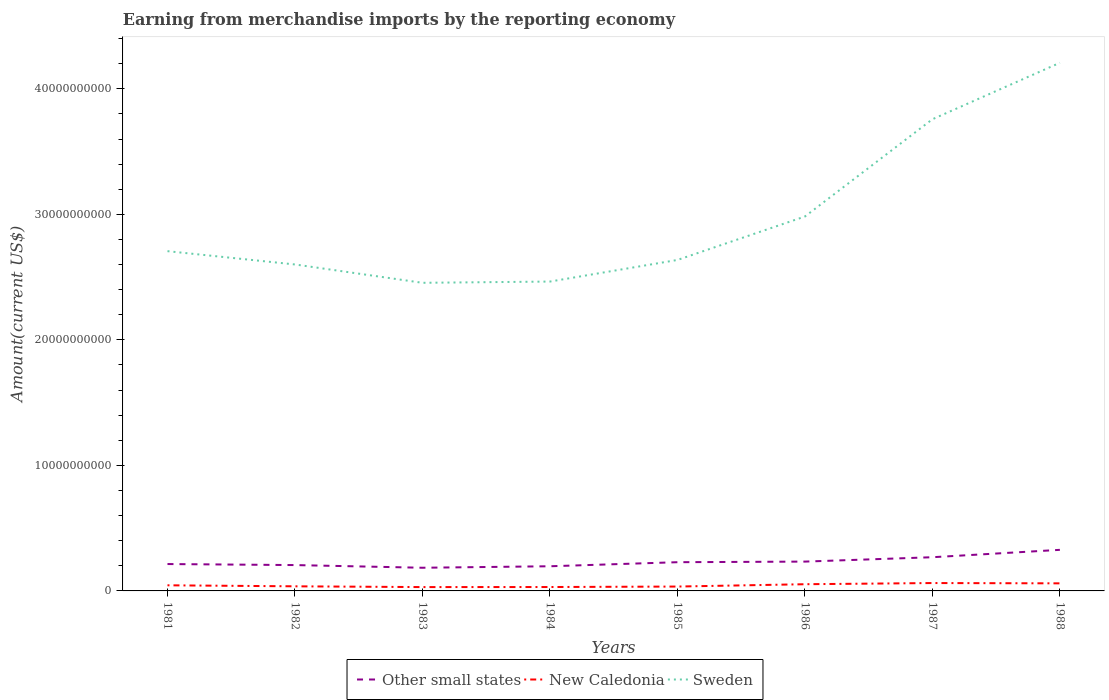Does the line corresponding to Other small states intersect with the line corresponding to New Caledonia?
Ensure brevity in your answer.  No. Across all years, what is the maximum amount earned from merchandise imports in Sweden?
Your answer should be very brief. 2.45e+1. What is the total amount earned from merchandise imports in New Caledonia in the graph?
Keep it short and to the point. 9.94e+07. What is the difference between the highest and the second highest amount earned from merchandise imports in New Caledonia?
Offer a terse response. 3.22e+08. What is the difference between the highest and the lowest amount earned from merchandise imports in Sweden?
Provide a succinct answer. 3. Does the graph contain grids?
Make the answer very short. No. How many legend labels are there?
Your answer should be very brief. 3. How are the legend labels stacked?
Provide a short and direct response. Horizontal. What is the title of the graph?
Offer a terse response. Earning from merchandise imports by the reporting economy. Does "Philippines" appear as one of the legend labels in the graph?
Provide a short and direct response. No. What is the label or title of the Y-axis?
Keep it short and to the point. Amount(current US$). What is the Amount(current US$) of Other small states in 1981?
Provide a short and direct response. 2.14e+09. What is the Amount(current US$) of New Caledonia in 1981?
Keep it short and to the point. 4.48e+08. What is the Amount(current US$) in Sweden in 1981?
Ensure brevity in your answer.  2.71e+1. What is the Amount(current US$) of Other small states in 1982?
Keep it short and to the point. 2.06e+09. What is the Amount(current US$) in New Caledonia in 1982?
Keep it short and to the point. 3.67e+08. What is the Amount(current US$) in Sweden in 1982?
Offer a terse response. 2.60e+1. What is the Amount(current US$) of Other small states in 1983?
Offer a very short reply. 1.85e+09. What is the Amount(current US$) in New Caledonia in 1983?
Make the answer very short. 3.06e+08. What is the Amount(current US$) in Sweden in 1983?
Your response must be concise. 2.45e+1. What is the Amount(current US$) of Other small states in 1984?
Your answer should be compact. 1.96e+09. What is the Amount(current US$) in New Caledonia in 1984?
Make the answer very short. 3.10e+08. What is the Amount(current US$) in Sweden in 1984?
Your answer should be very brief. 2.46e+1. What is the Amount(current US$) in Other small states in 1985?
Your response must be concise. 2.29e+09. What is the Amount(current US$) of New Caledonia in 1985?
Offer a terse response. 3.48e+08. What is the Amount(current US$) of Sweden in 1985?
Provide a succinct answer. 2.64e+1. What is the Amount(current US$) of Other small states in 1986?
Provide a succinct answer. 2.34e+09. What is the Amount(current US$) of New Caledonia in 1986?
Ensure brevity in your answer.  5.34e+08. What is the Amount(current US$) of Sweden in 1986?
Ensure brevity in your answer.  2.98e+1. What is the Amount(current US$) of Other small states in 1987?
Your answer should be very brief. 2.68e+09. What is the Amount(current US$) of New Caledonia in 1987?
Your answer should be compact. 6.27e+08. What is the Amount(current US$) of Sweden in 1987?
Your response must be concise. 3.76e+1. What is the Amount(current US$) in Other small states in 1988?
Your answer should be compact. 3.27e+09. What is the Amount(current US$) of New Caledonia in 1988?
Make the answer very short. 6.04e+08. What is the Amount(current US$) of Sweden in 1988?
Your response must be concise. 4.21e+1. Across all years, what is the maximum Amount(current US$) in Other small states?
Provide a short and direct response. 3.27e+09. Across all years, what is the maximum Amount(current US$) in New Caledonia?
Offer a terse response. 6.27e+08. Across all years, what is the maximum Amount(current US$) in Sweden?
Your response must be concise. 4.21e+1. Across all years, what is the minimum Amount(current US$) in Other small states?
Your response must be concise. 1.85e+09. Across all years, what is the minimum Amount(current US$) of New Caledonia?
Provide a short and direct response. 3.06e+08. Across all years, what is the minimum Amount(current US$) in Sweden?
Your answer should be compact. 2.45e+1. What is the total Amount(current US$) in Other small states in the graph?
Ensure brevity in your answer.  1.86e+1. What is the total Amount(current US$) of New Caledonia in the graph?
Ensure brevity in your answer.  3.54e+09. What is the total Amount(current US$) in Sweden in the graph?
Give a very brief answer. 2.38e+11. What is the difference between the Amount(current US$) in Other small states in 1981 and that in 1982?
Offer a very short reply. 8.25e+07. What is the difference between the Amount(current US$) of New Caledonia in 1981 and that in 1982?
Provide a succinct answer. 8.07e+07. What is the difference between the Amount(current US$) in Sweden in 1981 and that in 1982?
Provide a succinct answer. 1.06e+09. What is the difference between the Amount(current US$) of Other small states in 1981 and that in 1983?
Ensure brevity in your answer.  2.95e+08. What is the difference between the Amount(current US$) of New Caledonia in 1981 and that in 1983?
Your answer should be compact. 1.42e+08. What is the difference between the Amount(current US$) of Sweden in 1981 and that in 1983?
Give a very brief answer. 2.52e+09. What is the difference between the Amount(current US$) in Other small states in 1981 and that in 1984?
Your answer should be compact. 1.77e+08. What is the difference between the Amount(current US$) in New Caledonia in 1981 and that in 1984?
Offer a very short reply. 1.37e+08. What is the difference between the Amount(current US$) in Sweden in 1981 and that in 1984?
Ensure brevity in your answer.  2.42e+09. What is the difference between the Amount(current US$) of Other small states in 1981 and that in 1985?
Offer a very short reply. -1.46e+08. What is the difference between the Amount(current US$) in New Caledonia in 1981 and that in 1985?
Offer a very short reply. 9.94e+07. What is the difference between the Amount(current US$) in Sweden in 1981 and that in 1985?
Offer a very short reply. 7.01e+08. What is the difference between the Amount(current US$) of Other small states in 1981 and that in 1986?
Your answer should be compact. -1.95e+08. What is the difference between the Amount(current US$) in New Caledonia in 1981 and that in 1986?
Offer a very short reply. -8.64e+07. What is the difference between the Amount(current US$) of Sweden in 1981 and that in 1986?
Ensure brevity in your answer.  -2.76e+09. What is the difference between the Amount(current US$) in Other small states in 1981 and that in 1987?
Give a very brief answer. -5.43e+08. What is the difference between the Amount(current US$) in New Caledonia in 1981 and that in 1987?
Your answer should be compact. -1.80e+08. What is the difference between the Amount(current US$) in Sweden in 1981 and that in 1987?
Your response must be concise. -1.05e+1. What is the difference between the Amount(current US$) of Other small states in 1981 and that in 1988?
Keep it short and to the point. -1.13e+09. What is the difference between the Amount(current US$) of New Caledonia in 1981 and that in 1988?
Your answer should be compact. -1.56e+08. What is the difference between the Amount(current US$) in Sweden in 1981 and that in 1988?
Provide a short and direct response. -1.50e+1. What is the difference between the Amount(current US$) in Other small states in 1982 and that in 1983?
Give a very brief answer. 2.13e+08. What is the difference between the Amount(current US$) of New Caledonia in 1982 and that in 1983?
Provide a short and direct response. 6.10e+07. What is the difference between the Amount(current US$) in Sweden in 1982 and that in 1983?
Your answer should be very brief. 1.46e+09. What is the difference between the Amount(current US$) in Other small states in 1982 and that in 1984?
Your answer should be compact. 9.45e+07. What is the difference between the Amount(current US$) in New Caledonia in 1982 and that in 1984?
Your answer should be very brief. 5.65e+07. What is the difference between the Amount(current US$) in Sweden in 1982 and that in 1984?
Provide a short and direct response. 1.36e+09. What is the difference between the Amount(current US$) of Other small states in 1982 and that in 1985?
Your answer should be very brief. -2.29e+08. What is the difference between the Amount(current US$) in New Caledonia in 1982 and that in 1985?
Offer a terse response. 1.87e+07. What is the difference between the Amount(current US$) of Sweden in 1982 and that in 1985?
Provide a succinct answer. -3.59e+08. What is the difference between the Amount(current US$) of Other small states in 1982 and that in 1986?
Make the answer very short. -2.77e+08. What is the difference between the Amount(current US$) of New Caledonia in 1982 and that in 1986?
Your response must be concise. -1.67e+08. What is the difference between the Amount(current US$) in Sweden in 1982 and that in 1986?
Make the answer very short. -3.82e+09. What is the difference between the Amount(current US$) of Other small states in 1982 and that in 1987?
Offer a very short reply. -6.25e+08. What is the difference between the Amount(current US$) of New Caledonia in 1982 and that in 1987?
Your answer should be compact. -2.61e+08. What is the difference between the Amount(current US$) of Sweden in 1982 and that in 1987?
Keep it short and to the point. -1.16e+1. What is the difference between the Amount(current US$) in Other small states in 1982 and that in 1988?
Give a very brief answer. -1.21e+09. What is the difference between the Amount(current US$) in New Caledonia in 1982 and that in 1988?
Ensure brevity in your answer.  -2.37e+08. What is the difference between the Amount(current US$) in Sweden in 1982 and that in 1988?
Your response must be concise. -1.61e+1. What is the difference between the Amount(current US$) of Other small states in 1983 and that in 1984?
Your answer should be very brief. -1.18e+08. What is the difference between the Amount(current US$) of New Caledonia in 1983 and that in 1984?
Make the answer very short. -4.48e+06. What is the difference between the Amount(current US$) of Sweden in 1983 and that in 1984?
Your answer should be compact. -9.96e+07. What is the difference between the Amount(current US$) of Other small states in 1983 and that in 1985?
Give a very brief answer. -4.42e+08. What is the difference between the Amount(current US$) in New Caledonia in 1983 and that in 1985?
Offer a terse response. -4.22e+07. What is the difference between the Amount(current US$) in Sweden in 1983 and that in 1985?
Offer a very short reply. -1.82e+09. What is the difference between the Amount(current US$) in Other small states in 1983 and that in 1986?
Your response must be concise. -4.90e+08. What is the difference between the Amount(current US$) in New Caledonia in 1983 and that in 1986?
Provide a short and direct response. -2.28e+08. What is the difference between the Amount(current US$) of Sweden in 1983 and that in 1986?
Provide a short and direct response. -5.28e+09. What is the difference between the Amount(current US$) of Other small states in 1983 and that in 1987?
Make the answer very short. -8.38e+08. What is the difference between the Amount(current US$) in New Caledonia in 1983 and that in 1987?
Provide a short and direct response. -3.22e+08. What is the difference between the Amount(current US$) in Sweden in 1983 and that in 1987?
Provide a succinct answer. -1.30e+1. What is the difference between the Amount(current US$) in Other small states in 1983 and that in 1988?
Ensure brevity in your answer.  -1.43e+09. What is the difference between the Amount(current US$) in New Caledonia in 1983 and that in 1988?
Give a very brief answer. -2.98e+08. What is the difference between the Amount(current US$) in Sweden in 1983 and that in 1988?
Give a very brief answer. -1.75e+1. What is the difference between the Amount(current US$) of Other small states in 1984 and that in 1985?
Provide a succinct answer. -3.23e+08. What is the difference between the Amount(current US$) of New Caledonia in 1984 and that in 1985?
Make the answer very short. -3.77e+07. What is the difference between the Amount(current US$) of Sweden in 1984 and that in 1985?
Make the answer very short. -1.72e+09. What is the difference between the Amount(current US$) of Other small states in 1984 and that in 1986?
Provide a short and direct response. -3.72e+08. What is the difference between the Amount(current US$) in New Caledonia in 1984 and that in 1986?
Provide a short and direct response. -2.24e+08. What is the difference between the Amount(current US$) in Sweden in 1984 and that in 1986?
Your response must be concise. -5.18e+09. What is the difference between the Amount(current US$) in Other small states in 1984 and that in 1987?
Make the answer very short. -7.20e+08. What is the difference between the Amount(current US$) in New Caledonia in 1984 and that in 1987?
Make the answer very short. -3.17e+08. What is the difference between the Amount(current US$) of Sweden in 1984 and that in 1987?
Keep it short and to the point. -1.29e+1. What is the difference between the Amount(current US$) of Other small states in 1984 and that in 1988?
Make the answer very short. -1.31e+09. What is the difference between the Amount(current US$) in New Caledonia in 1984 and that in 1988?
Make the answer very short. -2.93e+08. What is the difference between the Amount(current US$) in Sweden in 1984 and that in 1988?
Provide a succinct answer. -1.74e+1. What is the difference between the Amount(current US$) in Other small states in 1985 and that in 1986?
Provide a succinct answer. -4.85e+07. What is the difference between the Amount(current US$) of New Caledonia in 1985 and that in 1986?
Offer a terse response. -1.86e+08. What is the difference between the Amount(current US$) of Sweden in 1985 and that in 1986?
Your answer should be compact. -3.46e+09. What is the difference between the Amount(current US$) in Other small states in 1985 and that in 1987?
Provide a succinct answer. -3.96e+08. What is the difference between the Amount(current US$) of New Caledonia in 1985 and that in 1987?
Your answer should be compact. -2.79e+08. What is the difference between the Amount(current US$) of Sweden in 1985 and that in 1987?
Offer a terse response. -1.12e+1. What is the difference between the Amount(current US$) in Other small states in 1985 and that in 1988?
Ensure brevity in your answer.  -9.85e+08. What is the difference between the Amount(current US$) of New Caledonia in 1985 and that in 1988?
Your answer should be very brief. -2.56e+08. What is the difference between the Amount(current US$) of Sweden in 1985 and that in 1988?
Your answer should be very brief. -1.57e+1. What is the difference between the Amount(current US$) of Other small states in 1986 and that in 1987?
Offer a very short reply. -3.48e+08. What is the difference between the Amount(current US$) in New Caledonia in 1986 and that in 1987?
Keep it short and to the point. -9.35e+07. What is the difference between the Amount(current US$) of Sweden in 1986 and that in 1987?
Your answer should be compact. -7.75e+09. What is the difference between the Amount(current US$) of Other small states in 1986 and that in 1988?
Your answer should be compact. -9.36e+08. What is the difference between the Amount(current US$) in New Caledonia in 1986 and that in 1988?
Give a very brief answer. -6.97e+07. What is the difference between the Amount(current US$) of Sweden in 1986 and that in 1988?
Give a very brief answer. -1.22e+1. What is the difference between the Amount(current US$) in Other small states in 1987 and that in 1988?
Provide a succinct answer. -5.88e+08. What is the difference between the Amount(current US$) in New Caledonia in 1987 and that in 1988?
Your answer should be compact. 2.38e+07. What is the difference between the Amount(current US$) in Sweden in 1987 and that in 1988?
Make the answer very short. -4.50e+09. What is the difference between the Amount(current US$) in Other small states in 1981 and the Amount(current US$) in New Caledonia in 1982?
Your response must be concise. 1.77e+09. What is the difference between the Amount(current US$) in Other small states in 1981 and the Amount(current US$) in Sweden in 1982?
Provide a short and direct response. -2.39e+1. What is the difference between the Amount(current US$) in New Caledonia in 1981 and the Amount(current US$) in Sweden in 1982?
Make the answer very short. -2.56e+1. What is the difference between the Amount(current US$) in Other small states in 1981 and the Amount(current US$) in New Caledonia in 1983?
Your answer should be very brief. 1.84e+09. What is the difference between the Amount(current US$) in Other small states in 1981 and the Amount(current US$) in Sweden in 1983?
Offer a very short reply. -2.24e+1. What is the difference between the Amount(current US$) of New Caledonia in 1981 and the Amount(current US$) of Sweden in 1983?
Give a very brief answer. -2.41e+1. What is the difference between the Amount(current US$) in Other small states in 1981 and the Amount(current US$) in New Caledonia in 1984?
Keep it short and to the point. 1.83e+09. What is the difference between the Amount(current US$) of Other small states in 1981 and the Amount(current US$) of Sweden in 1984?
Ensure brevity in your answer.  -2.25e+1. What is the difference between the Amount(current US$) of New Caledonia in 1981 and the Amount(current US$) of Sweden in 1984?
Make the answer very short. -2.42e+1. What is the difference between the Amount(current US$) of Other small states in 1981 and the Amount(current US$) of New Caledonia in 1985?
Keep it short and to the point. 1.79e+09. What is the difference between the Amount(current US$) in Other small states in 1981 and the Amount(current US$) in Sweden in 1985?
Offer a very short reply. -2.42e+1. What is the difference between the Amount(current US$) of New Caledonia in 1981 and the Amount(current US$) of Sweden in 1985?
Provide a succinct answer. -2.59e+1. What is the difference between the Amount(current US$) of Other small states in 1981 and the Amount(current US$) of New Caledonia in 1986?
Your answer should be compact. 1.61e+09. What is the difference between the Amount(current US$) in Other small states in 1981 and the Amount(current US$) in Sweden in 1986?
Your answer should be very brief. -2.77e+1. What is the difference between the Amount(current US$) in New Caledonia in 1981 and the Amount(current US$) in Sweden in 1986?
Keep it short and to the point. -2.94e+1. What is the difference between the Amount(current US$) of Other small states in 1981 and the Amount(current US$) of New Caledonia in 1987?
Provide a short and direct response. 1.51e+09. What is the difference between the Amount(current US$) of Other small states in 1981 and the Amount(current US$) of Sweden in 1987?
Your answer should be very brief. -3.54e+1. What is the difference between the Amount(current US$) of New Caledonia in 1981 and the Amount(current US$) of Sweden in 1987?
Make the answer very short. -3.71e+1. What is the difference between the Amount(current US$) of Other small states in 1981 and the Amount(current US$) of New Caledonia in 1988?
Give a very brief answer. 1.54e+09. What is the difference between the Amount(current US$) of Other small states in 1981 and the Amount(current US$) of Sweden in 1988?
Give a very brief answer. -3.99e+1. What is the difference between the Amount(current US$) in New Caledonia in 1981 and the Amount(current US$) in Sweden in 1988?
Provide a succinct answer. -4.16e+1. What is the difference between the Amount(current US$) of Other small states in 1982 and the Amount(current US$) of New Caledonia in 1983?
Offer a terse response. 1.75e+09. What is the difference between the Amount(current US$) in Other small states in 1982 and the Amount(current US$) in Sweden in 1983?
Offer a very short reply. -2.25e+1. What is the difference between the Amount(current US$) in New Caledonia in 1982 and the Amount(current US$) in Sweden in 1983?
Your answer should be compact. -2.42e+1. What is the difference between the Amount(current US$) in Other small states in 1982 and the Amount(current US$) in New Caledonia in 1984?
Offer a terse response. 1.75e+09. What is the difference between the Amount(current US$) in Other small states in 1982 and the Amount(current US$) in Sweden in 1984?
Your response must be concise. -2.26e+1. What is the difference between the Amount(current US$) in New Caledonia in 1982 and the Amount(current US$) in Sweden in 1984?
Your answer should be compact. -2.43e+1. What is the difference between the Amount(current US$) of Other small states in 1982 and the Amount(current US$) of New Caledonia in 1985?
Offer a very short reply. 1.71e+09. What is the difference between the Amount(current US$) in Other small states in 1982 and the Amount(current US$) in Sweden in 1985?
Provide a short and direct response. -2.43e+1. What is the difference between the Amount(current US$) in New Caledonia in 1982 and the Amount(current US$) in Sweden in 1985?
Offer a very short reply. -2.60e+1. What is the difference between the Amount(current US$) in Other small states in 1982 and the Amount(current US$) in New Caledonia in 1986?
Offer a terse response. 1.53e+09. What is the difference between the Amount(current US$) in Other small states in 1982 and the Amount(current US$) in Sweden in 1986?
Your response must be concise. -2.78e+1. What is the difference between the Amount(current US$) in New Caledonia in 1982 and the Amount(current US$) in Sweden in 1986?
Provide a short and direct response. -2.95e+1. What is the difference between the Amount(current US$) in Other small states in 1982 and the Amount(current US$) in New Caledonia in 1987?
Provide a succinct answer. 1.43e+09. What is the difference between the Amount(current US$) of Other small states in 1982 and the Amount(current US$) of Sweden in 1987?
Make the answer very short. -3.55e+1. What is the difference between the Amount(current US$) in New Caledonia in 1982 and the Amount(current US$) in Sweden in 1987?
Provide a succinct answer. -3.72e+1. What is the difference between the Amount(current US$) of Other small states in 1982 and the Amount(current US$) of New Caledonia in 1988?
Ensure brevity in your answer.  1.46e+09. What is the difference between the Amount(current US$) in Other small states in 1982 and the Amount(current US$) in Sweden in 1988?
Offer a very short reply. -4.00e+1. What is the difference between the Amount(current US$) in New Caledonia in 1982 and the Amount(current US$) in Sweden in 1988?
Offer a terse response. -4.17e+1. What is the difference between the Amount(current US$) in Other small states in 1983 and the Amount(current US$) in New Caledonia in 1984?
Make the answer very short. 1.54e+09. What is the difference between the Amount(current US$) of Other small states in 1983 and the Amount(current US$) of Sweden in 1984?
Offer a terse response. -2.28e+1. What is the difference between the Amount(current US$) in New Caledonia in 1983 and the Amount(current US$) in Sweden in 1984?
Your response must be concise. -2.43e+1. What is the difference between the Amount(current US$) of Other small states in 1983 and the Amount(current US$) of New Caledonia in 1985?
Your answer should be very brief. 1.50e+09. What is the difference between the Amount(current US$) of Other small states in 1983 and the Amount(current US$) of Sweden in 1985?
Ensure brevity in your answer.  -2.45e+1. What is the difference between the Amount(current US$) of New Caledonia in 1983 and the Amount(current US$) of Sweden in 1985?
Your answer should be very brief. -2.61e+1. What is the difference between the Amount(current US$) in Other small states in 1983 and the Amount(current US$) in New Caledonia in 1986?
Ensure brevity in your answer.  1.31e+09. What is the difference between the Amount(current US$) in Other small states in 1983 and the Amount(current US$) in Sweden in 1986?
Give a very brief answer. -2.80e+1. What is the difference between the Amount(current US$) in New Caledonia in 1983 and the Amount(current US$) in Sweden in 1986?
Ensure brevity in your answer.  -2.95e+1. What is the difference between the Amount(current US$) of Other small states in 1983 and the Amount(current US$) of New Caledonia in 1987?
Offer a terse response. 1.22e+09. What is the difference between the Amount(current US$) of Other small states in 1983 and the Amount(current US$) of Sweden in 1987?
Ensure brevity in your answer.  -3.57e+1. What is the difference between the Amount(current US$) in New Caledonia in 1983 and the Amount(current US$) in Sweden in 1987?
Ensure brevity in your answer.  -3.73e+1. What is the difference between the Amount(current US$) of Other small states in 1983 and the Amount(current US$) of New Caledonia in 1988?
Keep it short and to the point. 1.24e+09. What is the difference between the Amount(current US$) in Other small states in 1983 and the Amount(current US$) in Sweden in 1988?
Ensure brevity in your answer.  -4.02e+1. What is the difference between the Amount(current US$) of New Caledonia in 1983 and the Amount(current US$) of Sweden in 1988?
Provide a short and direct response. -4.18e+1. What is the difference between the Amount(current US$) of Other small states in 1984 and the Amount(current US$) of New Caledonia in 1985?
Keep it short and to the point. 1.62e+09. What is the difference between the Amount(current US$) in Other small states in 1984 and the Amount(current US$) in Sweden in 1985?
Your answer should be very brief. -2.44e+1. What is the difference between the Amount(current US$) of New Caledonia in 1984 and the Amount(current US$) of Sweden in 1985?
Offer a very short reply. -2.61e+1. What is the difference between the Amount(current US$) of Other small states in 1984 and the Amount(current US$) of New Caledonia in 1986?
Offer a very short reply. 1.43e+09. What is the difference between the Amount(current US$) in Other small states in 1984 and the Amount(current US$) in Sweden in 1986?
Provide a short and direct response. -2.79e+1. What is the difference between the Amount(current US$) in New Caledonia in 1984 and the Amount(current US$) in Sweden in 1986?
Keep it short and to the point. -2.95e+1. What is the difference between the Amount(current US$) in Other small states in 1984 and the Amount(current US$) in New Caledonia in 1987?
Your answer should be very brief. 1.34e+09. What is the difference between the Amount(current US$) of Other small states in 1984 and the Amount(current US$) of Sweden in 1987?
Your answer should be compact. -3.56e+1. What is the difference between the Amount(current US$) in New Caledonia in 1984 and the Amount(current US$) in Sweden in 1987?
Offer a terse response. -3.73e+1. What is the difference between the Amount(current US$) in Other small states in 1984 and the Amount(current US$) in New Caledonia in 1988?
Your response must be concise. 1.36e+09. What is the difference between the Amount(current US$) in Other small states in 1984 and the Amount(current US$) in Sweden in 1988?
Provide a short and direct response. -4.01e+1. What is the difference between the Amount(current US$) of New Caledonia in 1984 and the Amount(current US$) of Sweden in 1988?
Give a very brief answer. -4.18e+1. What is the difference between the Amount(current US$) in Other small states in 1985 and the Amount(current US$) in New Caledonia in 1986?
Your answer should be very brief. 1.75e+09. What is the difference between the Amount(current US$) in Other small states in 1985 and the Amount(current US$) in Sweden in 1986?
Your answer should be very brief. -2.75e+1. What is the difference between the Amount(current US$) of New Caledonia in 1985 and the Amount(current US$) of Sweden in 1986?
Provide a short and direct response. -2.95e+1. What is the difference between the Amount(current US$) of Other small states in 1985 and the Amount(current US$) of New Caledonia in 1987?
Your response must be concise. 1.66e+09. What is the difference between the Amount(current US$) of Other small states in 1985 and the Amount(current US$) of Sweden in 1987?
Your answer should be compact. -3.53e+1. What is the difference between the Amount(current US$) of New Caledonia in 1985 and the Amount(current US$) of Sweden in 1987?
Your response must be concise. -3.72e+1. What is the difference between the Amount(current US$) of Other small states in 1985 and the Amount(current US$) of New Caledonia in 1988?
Your answer should be very brief. 1.68e+09. What is the difference between the Amount(current US$) of Other small states in 1985 and the Amount(current US$) of Sweden in 1988?
Offer a terse response. -3.98e+1. What is the difference between the Amount(current US$) in New Caledonia in 1985 and the Amount(current US$) in Sweden in 1988?
Give a very brief answer. -4.17e+1. What is the difference between the Amount(current US$) in Other small states in 1986 and the Amount(current US$) in New Caledonia in 1987?
Provide a succinct answer. 1.71e+09. What is the difference between the Amount(current US$) of Other small states in 1986 and the Amount(current US$) of Sweden in 1987?
Make the answer very short. -3.52e+1. What is the difference between the Amount(current US$) of New Caledonia in 1986 and the Amount(current US$) of Sweden in 1987?
Give a very brief answer. -3.70e+1. What is the difference between the Amount(current US$) in Other small states in 1986 and the Amount(current US$) in New Caledonia in 1988?
Make the answer very short. 1.73e+09. What is the difference between the Amount(current US$) of Other small states in 1986 and the Amount(current US$) of Sweden in 1988?
Give a very brief answer. -3.97e+1. What is the difference between the Amount(current US$) of New Caledonia in 1986 and the Amount(current US$) of Sweden in 1988?
Provide a short and direct response. -4.15e+1. What is the difference between the Amount(current US$) of Other small states in 1987 and the Amount(current US$) of New Caledonia in 1988?
Offer a terse response. 2.08e+09. What is the difference between the Amount(current US$) of Other small states in 1987 and the Amount(current US$) of Sweden in 1988?
Your answer should be very brief. -3.94e+1. What is the difference between the Amount(current US$) of New Caledonia in 1987 and the Amount(current US$) of Sweden in 1988?
Your response must be concise. -4.14e+1. What is the average Amount(current US$) in Other small states per year?
Keep it short and to the point. 2.32e+09. What is the average Amount(current US$) of New Caledonia per year?
Your response must be concise. 4.43e+08. What is the average Amount(current US$) in Sweden per year?
Offer a very short reply. 2.98e+1. In the year 1981, what is the difference between the Amount(current US$) of Other small states and Amount(current US$) of New Caledonia?
Offer a very short reply. 1.69e+09. In the year 1981, what is the difference between the Amount(current US$) in Other small states and Amount(current US$) in Sweden?
Give a very brief answer. -2.49e+1. In the year 1981, what is the difference between the Amount(current US$) in New Caledonia and Amount(current US$) in Sweden?
Keep it short and to the point. -2.66e+1. In the year 1982, what is the difference between the Amount(current US$) of Other small states and Amount(current US$) of New Caledonia?
Make the answer very short. 1.69e+09. In the year 1982, what is the difference between the Amount(current US$) of Other small states and Amount(current US$) of Sweden?
Your answer should be compact. -2.39e+1. In the year 1982, what is the difference between the Amount(current US$) in New Caledonia and Amount(current US$) in Sweden?
Make the answer very short. -2.56e+1. In the year 1983, what is the difference between the Amount(current US$) of Other small states and Amount(current US$) of New Caledonia?
Make the answer very short. 1.54e+09. In the year 1983, what is the difference between the Amount(current US$) of Other small states and Amount(current US$) of Sweden?
Offer a terse response. -2.27e+1. In the year 1983, what is the difference between the Amount(current US$) in New Caledonia and Amount(current US$) in Sweden?
Your answer should be very brief. -2.42e+1. In the year 1984, what is the difference between the Amount(current US$) in Other small states and Amount(current US$) in New Caledonia?
Your answer should be very brief. 1.65e+09. In the year 1984, what is the difference between the Amount(current US$) in Other small states and Amount(current US$) in Sweden?
Give a very brief answer. -2.27e+1. In the year 1984, what is the difference between the Amount(current US$) of New Caledonia and Amount(current US$) of Sweden?
Keep it short and to the point. -2.43e+1. In the year 1985, what is the difference between the Amount(current US$) of Other small states and Amount(current US$) of New Caledonia?
Your answer should be very brief. 1.94e+09. In the year 1985, what is the difference between the Amount(current US$) in Other small states and Amount(current US$) in Sweden?
Provide a short and direct response. -2.41e+1. In the year 1985, what is the difference between the Amount(current US$) of New Caledonia and Amount(current US$) of Sweden?
Provide a succinct answer. -2.60e+1. In the year 1986, what is the difference between the Amount(current US$) of Other small states and Amount(current US$) of New Caledonia?
Keep it short and to the point. 1.80e+09. In the year 1986, what is the difference between the Amount(current US$) in Other small states and Amount(current US$) in Sweden?
Your response must be concise. -2.75e+1. In the year 1986, what is the difference between the Amount(current US$) in New Caledonia and Amount(current US$) in Sweden?
Offer a terse response. -2.93e+1. In the year 1987, what is the difference between the Amount(current US$) in Other small states and Amount(current US$) in New Caledonia?
Ensure brevity in your answer.  2.06e+09. In the year 1987, what is the difference between the Amount(current US$) of Other small states and Amount(current US$) of Sweden?
Your response must be concise. -3.49e+1. In the year 1987, what is the difference between the Amount(current US$) in New Caledonia and Amount(current US$) in Sweden?
Provide a short and direct response. -3.69e+1. In the year 1988, what is the difference between the Amount(current US$) of Other small states and Amount(current US$) of New Caledonia?
Provide a succinct answer. 2.67e+09. In the year 1988, what is the difference between the Amount(current US$) of Other small states and Amount(current US$) of Sweden?
Your answer should be very brief. -3.88e+1. In the year 1988, what is the difference between the Amount(current US$) of New Caledonia and Amount(current US$) of Sweden?
Ensure brevity in your answer.  -4.15e+1. What is the ratio of the Amount(current US$) of Other small states in 1981 to that in 1982?
Give a very brief answer. 1.04. What is the ratio of the Amount(current US$) in New Caledonia in 1981 to that in 1982?
Provide a short and direct response. 1.22. What is the ratio of the Amount(current US$) of Sweden in 1981 to that in 1982?
Your answer should be compact. 1.04. What is the ratio of the Amount(current US$) of Other small states in 1981 to that in 1983?
Offer a terse response. 1.16. What is the ratio of the Amount(current US$) in New Caledonia in 1981 to that in 1983?
Offer a terse response. 1.46. What is the ratio of the Amount(current US$) in Sweden in 1981 to that in 1983?
Offer a very short reply. 1.1. What is the ratio of the Amount(current US$) in Other small states in 1981 to that in 1984?
Provide a succinct answer. 1.09. What is the ratio of the Amount(current US$) of New Caledonia in 1981 to that in 1984?
Keep it short and to the point. 1.44. What is the ratio of the Amount(current US$) in Sweden in 1981 to that in 1984?
Make the answer very short. 1.1. What is the ratio of the Amount(current US$) in Other small states in 1981 to that in 1985?
Offer a terse response. 0.94. What is the ratio of the Amount(current US$) in New Caledonia in 1981 to that in 1985?
Your response must be concise. 1.29. What is the ratio of the Amount(current US$) in Sweden in 1981 to that in 1985?
Provide a short and direct response. 1.03. What is the ratio of the Amount(current US$) in Other small states in 1981 to that in 1986?
Give a very brief answer. 0.92. What is the ratio of the Amount(current US$) in New Caledonia in 1981 to that in 1986?
Your answer should be compact. 0.84. What is the ratio of the Amount(current US$) of Sweden in 1981 to that in 1986?
Offer a terse response. 0.91. What is the ratio of the Amount(current US$) in Other small states in 1981 to that in 1987?
Your answer should be very brief. 0.8. What is the ratio of the Amount(current US$) in New Caledonia in 1981 to that in 1987?
Offer a terse response. 0.71. What is the ratio of the Amount(current US$) in Sweden in 1981 to that in 1987?
Offer a terse response. 0.72. What is the ratio of the Amount(current US$) in Other small states in 1981 to that in 1988?
Provide a short and direct response. 0.65. What is the ratio of the Amount(current US$) of New Caledonia in 1981 to that in 1988?
Ensure brevity in your answer.  0.74. What is the ratio of the Amount(current US$) in Sweden in 1981 to that in 1988?
Your answer should be very brief. 0.64. What is the ratio of the Amount(current US$) in Other small states in 1982 to that in 1983?
Offer a very short reply. 1.12. What is the ratio of the Amount(current US$) in New Caledonia in 1982 to that in 1983?
Ensure brevity in your answer.  1.2. What is the ratio of the Amount(current US$) in Sweden in 1982 to that in 1983?
Your answer should be very brief. 1.06. What is the ratio of the Amount(current US$) in Other small states in 1982 to that in 1984?
Keep it short and to the point. 1.05. What is the ratio of the Amount(current US$) of New Caledonia in 1982 to that in 1984?
Your response must be concise. 1.18. What is the ratio of the Amount(current US$) of Sweden in 1982 to that in 1984?
Keep it short and to the point. 1.06. What is the ratio of the Amount(current US$) of Other small states in 1982 to that in 1985?
Provide a succinct answer. 0.9. What is the ratio of the Amount(current US$) in New Caledonia in 1982 to that in 1985?
Give a very brief answer. 1.05. What is the ratio of the Amount(current US$) of Sweden in 1982 to that in 1985?
Keep it short and to the point. 0.99. What is the ratio of the Amount(current US$) of Other small states in 1982 to that in 1986?
Provide a short and direct response. 0.88. What is the ratio of the Amount(current US$) in New Caledonia in 1982 to that in 1986?
Keep it short and to the point. 0.69. What is the ratio of the Amount(current US$) of Sweden in 1982 to that in 1986?
Your answer should be very brief. 0.87. What is the ratio of the Amount(current US$) of Other small states in 1982 to that in 1987?
Your response must be concise. 0.77. What is the ratio of the Amount(current US$) of New Caledonia in 1982 to that in 1987?
Your response must be concise. 0.58. What is the ratio of the Amount(current US$) in Sweden in 1982 to that in 1987?
Your response must be concise. 0.69. What is the ratio of the Amount(current US$) in Other small states in 1982 to that in 1988?
Ensure brevity in your answer.  0.63. What is the ratio of the Amount(current US$) in New Caledonia in 1982 to that in 1988?
Offer a very short reply. 0.61. What is the ratio of the Amount(current US$) in Sweden in 1982 to that in 1988?
Provide a short and direct response. 0.62. What is the ratio of the Amount(current US$) in Other small states in 1983 to that in 1984?
Ensure brevity in your answer.  0.94. What is the ratio of the Amount(current US$) in New Caledonia in 1983 to that in 1984?
Ensure brevity in your answer.  0.99. What is the ratio of the Amount(current US$) in Sweden in 1983 to that in 1984?
Ensure brevity in your answer.  1. What is the ratio of the Amount(current US$) in Other small states in 1983 to that in 1985?
Your answer should be compact. 0.81. What is the ratio of the Amount(current US$) of New Caledonia in 1983 to that in 1985?
Provide a succinct answer. 0.88. What is the ratio of the Amount(current US$) of Sweden in 1983 to that in 1985?
Your answer should be very brief. 0.93. What is the ratio of the Amount(current US$) in Other small states in 1983 to that in 1986?
Offer a very short reply. 0.79. What is the ratio of the Amount(current US$) in New Caledonia in 1983 to that in 1986?
Provide a short and direct response. 0.57. What is the ratio of the Amount(current US$) in Sweden in 1983 to that in 1986?
Your answer should be compact. 0.82. What is the ratio of the Amount(current US$) in Other small states in 1983 to that in 1987?
Provide a succinct answer. 0.69. What is the ratio of the Amount(current US$) of New Caledonia in 1983 to that in 1987?
Your answer should be very brief. 0.49. What is the ratio of the Amount(current US$) in Sweden in 1983 to that in 1987?
Offer a terse response. 0.65. What is the ratio of the Amount(current US$) in Other small states in 1983 to that in 1988?
Give a very brief answer. 0.56. What is the ratio of the Amount(current US$) in New Caledonia in 1983 to that in 1988?
Keep it short and to the point. 0.51. What is the ratio of the Amount(current US$) of Sweden in 1983 to that in 1988?
Offer a terse response. 0.58. What is the ratio of the Amount(current US$) of Other small states in 1984 to that in 1985?
Your answer should be compact. 0.86. What is the ratio of the Amount(current US$) of New Caledonia in 1984 to that in 1985?
Provide a short and direct response. 0.89. What is the ratio of the Amount(current US$) in Sweden in 1984 to that in 1985?
Offer a very short reply. 0.93. What is the ratio of the Amount(current US$) in Other small states in 1984 to that in 1986?
Your answer should be very brief. 0.84. What is the ratio of the Amount(current US$) in New Caledonia in 1984 to that in 1986?
Offer a terse response. 0.58. What is the ratio of the Amount(current US$) of Sweden in 1984 to that in 1986?
Make the answer very short. 0.83. What is the ratio of the Amount(current US$) of Other small states in 1984 to that in 1987?
Keep it short and to the point. 0.73. What is the ratio of the Amount(current US$) of New Caledonia in 1984 to that in 1987?
Offer a very short reply. 0.49. What is the ratio of the Amount(current US$) of Sweden in 1984 to that in 1987?
Your answer should be very brief. 0.66. What is the ratio of the Amount(current US$) of Other small states in 1984 to that in 1988?
Keep it short and to the point. 0.6. What is the ratio of the Amount(current US$) of New Caledonia in 1984 to that in 1988?
Provide a succinct answer. 0.51. What is the ratio of the Amount(current US$) in Sweden in 1984 to that in 1988?
Ensure brevity in your answer.  0.59. What is the ratio of the Amount(current US$) in Other small states in 1985 to that in 1986?
Ensure brevity in your answer.  0.98. What is the ratio of the Amount(current US$) in New Caledonia in 1985 to that in 1986?
Your answer should be compact. 0.65. What is the ratio of the Amount(current US$) of Sweden in 1985 to that in 1986?
Your answer should be compact. 0.88. What is the ratio of the Amount(current US$) in Other small states in 1985 to that in 1987?
Your answer should be very brief. 0.85. What is the ratio of the Amount(current US$) in New Caledonia in 1985 to that in 1987?
Provide a succinct answer. 0.55. What is the ratio of the Amount(current US$) in Sweden in 1985 to that in 1987?
Your response must be concise. 0.7. What is the ratio of the Amount(current US$) of Other small states in 1985 to that in 1988?
Give a very brief answer. 0.7. What is the ratio of the Amount(current US$) in New Caledonia in 1985 to that in 1988?
Ensure brevity in your answer.  0.58. What is the ratio of the Amount(current US$) in Sweden in 1985 to that in 1988?
Give a very brief answer. 0.63. What is the ratio of the Amount(current US$) of Other small states in 1986 to that in 1987?
Your answer should be compact. 0.87. What is the ratio of the Amount(current US$) of New Caledonia in 1986 to that in 1987?
Offer a very short reply. 0.85. What is the ratio of the Amount(current US$) of Sweden in 1986 to that in 1987?
Keep it short and to the point. 0.79. What is the ratio of the Amount(current US$) in Other small states in 1986 to that in 1988?
Give a very brief answer. 0.71. What is the ratio of the Amount(current US$) in New Caledonia in 1986 to that in 1988?
Ensure brevity in your answer.  0.88. What is the ratio of the Amount(current US$) of Sweden in 1986 to that in 1988?
Give a very brief answer. 0.71. What is the ratio of the Amount(current US$) of Other small states in 1987 to that in 1988?
Offer a terse response. 0.82. What is the ratio of the Amount(current US$) in New Caledonia in 1987 to that in 1988?
Offer a very short reply. 1.04. What is the ratio of the Amount(current US$) of Sweden in 1987 to that in 1988?
Provide a short and direct response. 0.89. What is the difference between the highest and the second highest Amount(current US$) in Other small states?
Your response must be concise. 5.88e+08. What is the difference between the highest and the second highest Amount(current US$) of New Caledonia?
Give a very brief answer. 2.38e+07. What is the difference between the highest and the second highest Amount(current US$) of Sweden?
Make the answer very short. 4.50e+09. What is the difference between the highest and the lowest Amount(current US$) of Other small states?
Your answer should be compact. 1.43e+09. What is the difference between the highest and the lowest Amount(current US$) of New Caledonia?
Your answer should be compact. 3.22e+08. What is the difference between the highest and the lowest Amount(current US$) in Sweden?
Provide a short and direct response. 1.75e+1. 